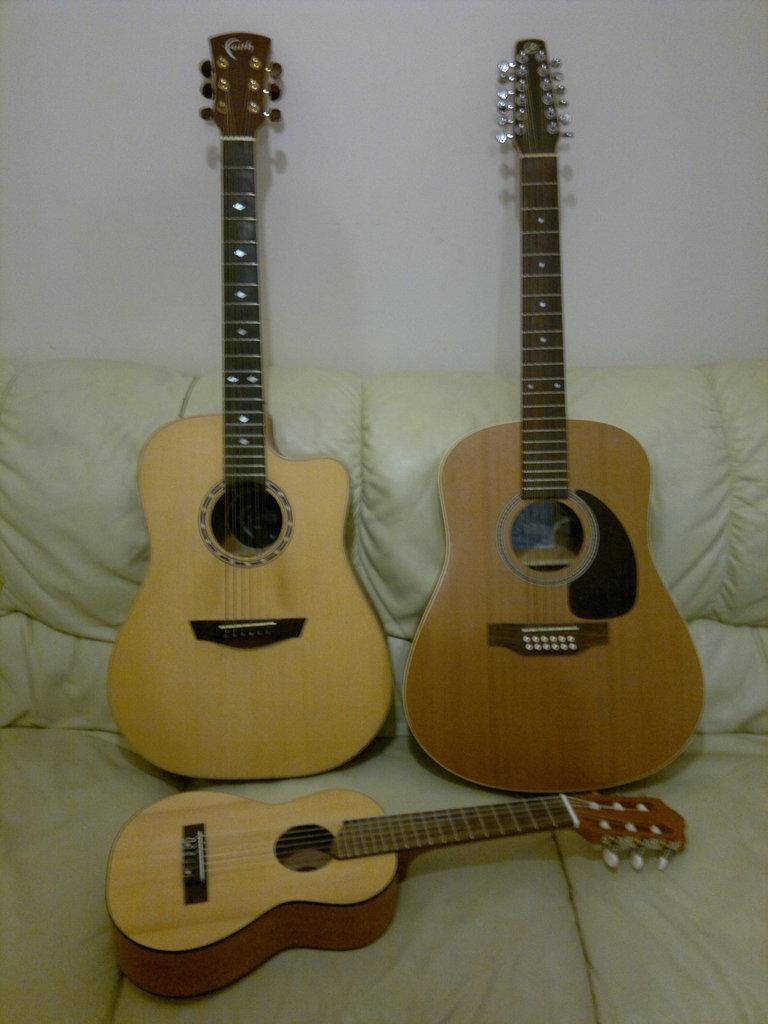What type of furniture is present in the image? There is a sofa in the image. What objects are placed on the sofa? There are three guitars on the sofa. What type of metal can be seen in the image? There is no metal visible in the image; it features a sofa with three guitars on it. What type of sport is being played in the image? There is no sport being played in the image; it features a sofa with three guitars on it. 